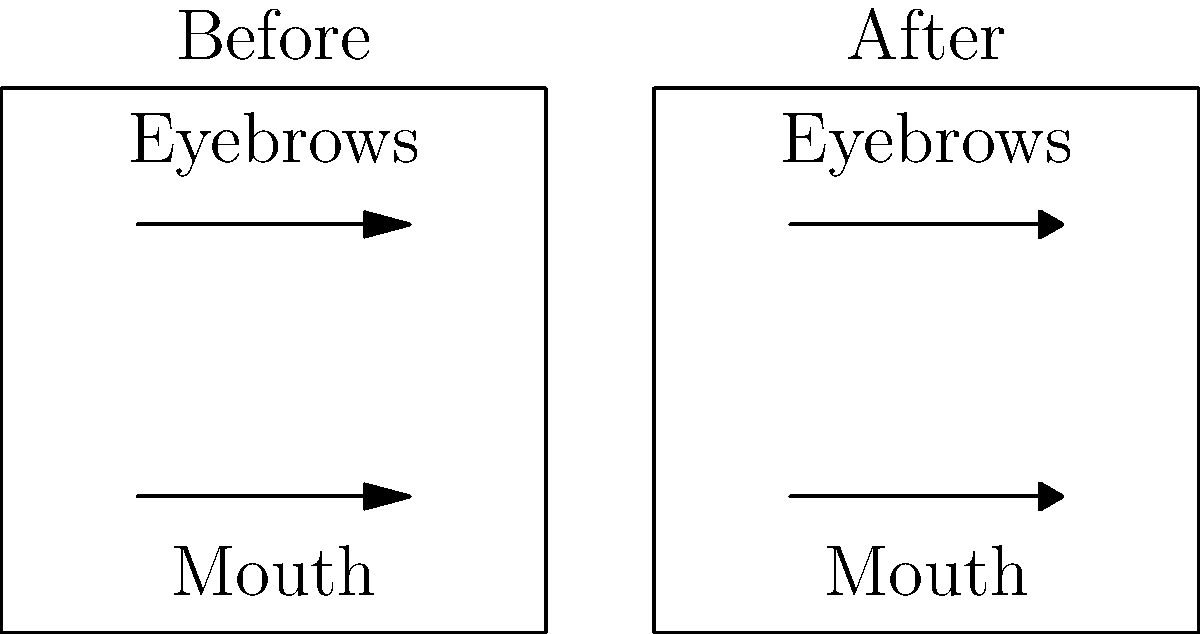As a photographer capturing the before and after transformation of a method actress, you notice significant changes in her facial expressions. In the diagram, straight arrows represent neutral expressions, while curved arrows indicate more dynamic expressions. What percentage increase in expressiveness do the curved arrows in the "After" image represent compared to the straight arrows in the "Before" image? To calculate the percentage increase in expressiveness, we'll follow these steps:

1. Assume the straight arrows in the "Before" image represent a baseline expressiveness of 100%.

2. The curved arrows in the "After" image suggest an increase in expressiveness. Let's assume each curved arrow represents a 50% increase over its straight counterpart.

3. Calculate the total expressiveness for the "After" image:
   100% (baseline) + 50% (increase) = 150% per feature

4. There are two features (eyebrows and mouth), so the total expressiveness remains at 150%.

5. Calculate the percentage increase:
   Percentage increase = $\frac{\text{Increase}}{\text{Original}} \times 100\%$
   $= \frac{150\% - 100\%}{100\%} \times 100\%$
   $= \frac{50\%}{100\%} \times 100\%$
   $= 50\%$

Therefore, the curved arrows in the "After" image represent a 50% increase in expressiveness compared to the straight arrows in the "Before" image.
Answer: 50% 